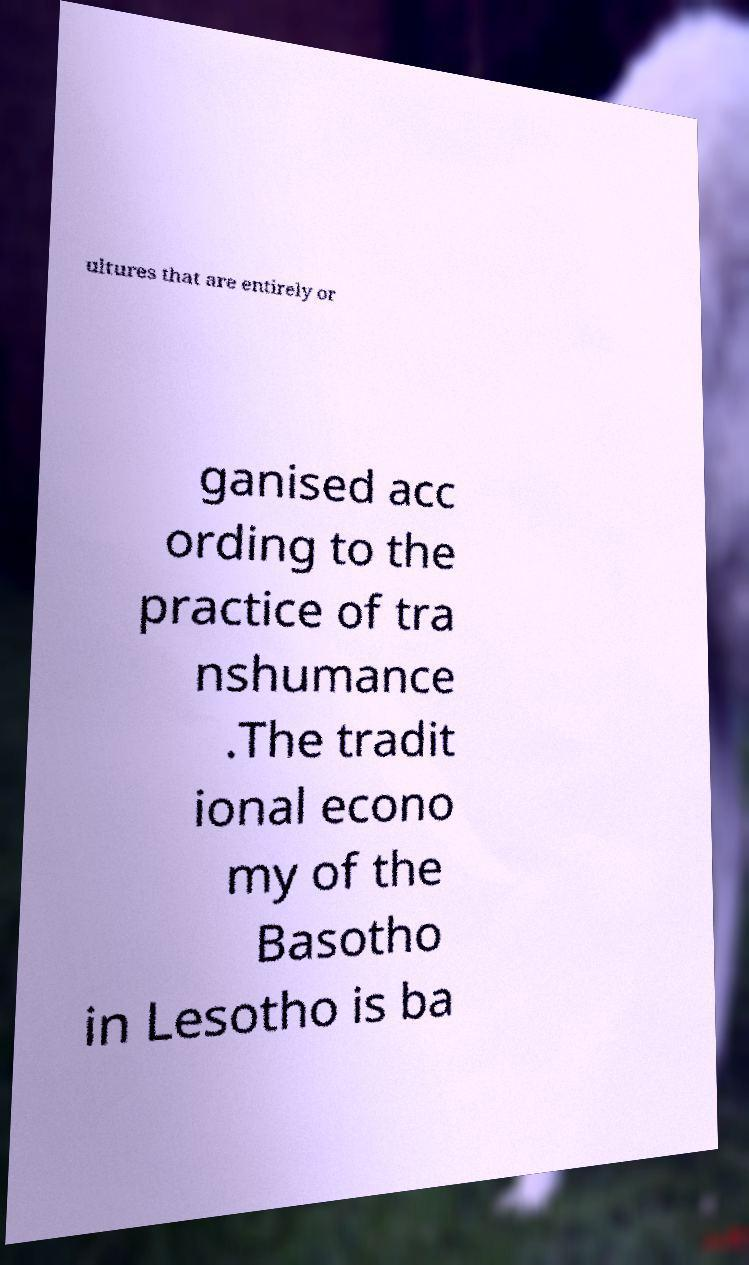Could you extract and type out the text from this image? ultures that are entirely or ganised acc ording to the practice of tra nshumance .The tradit ional econo my of the Basotho in Lesotho is ba 